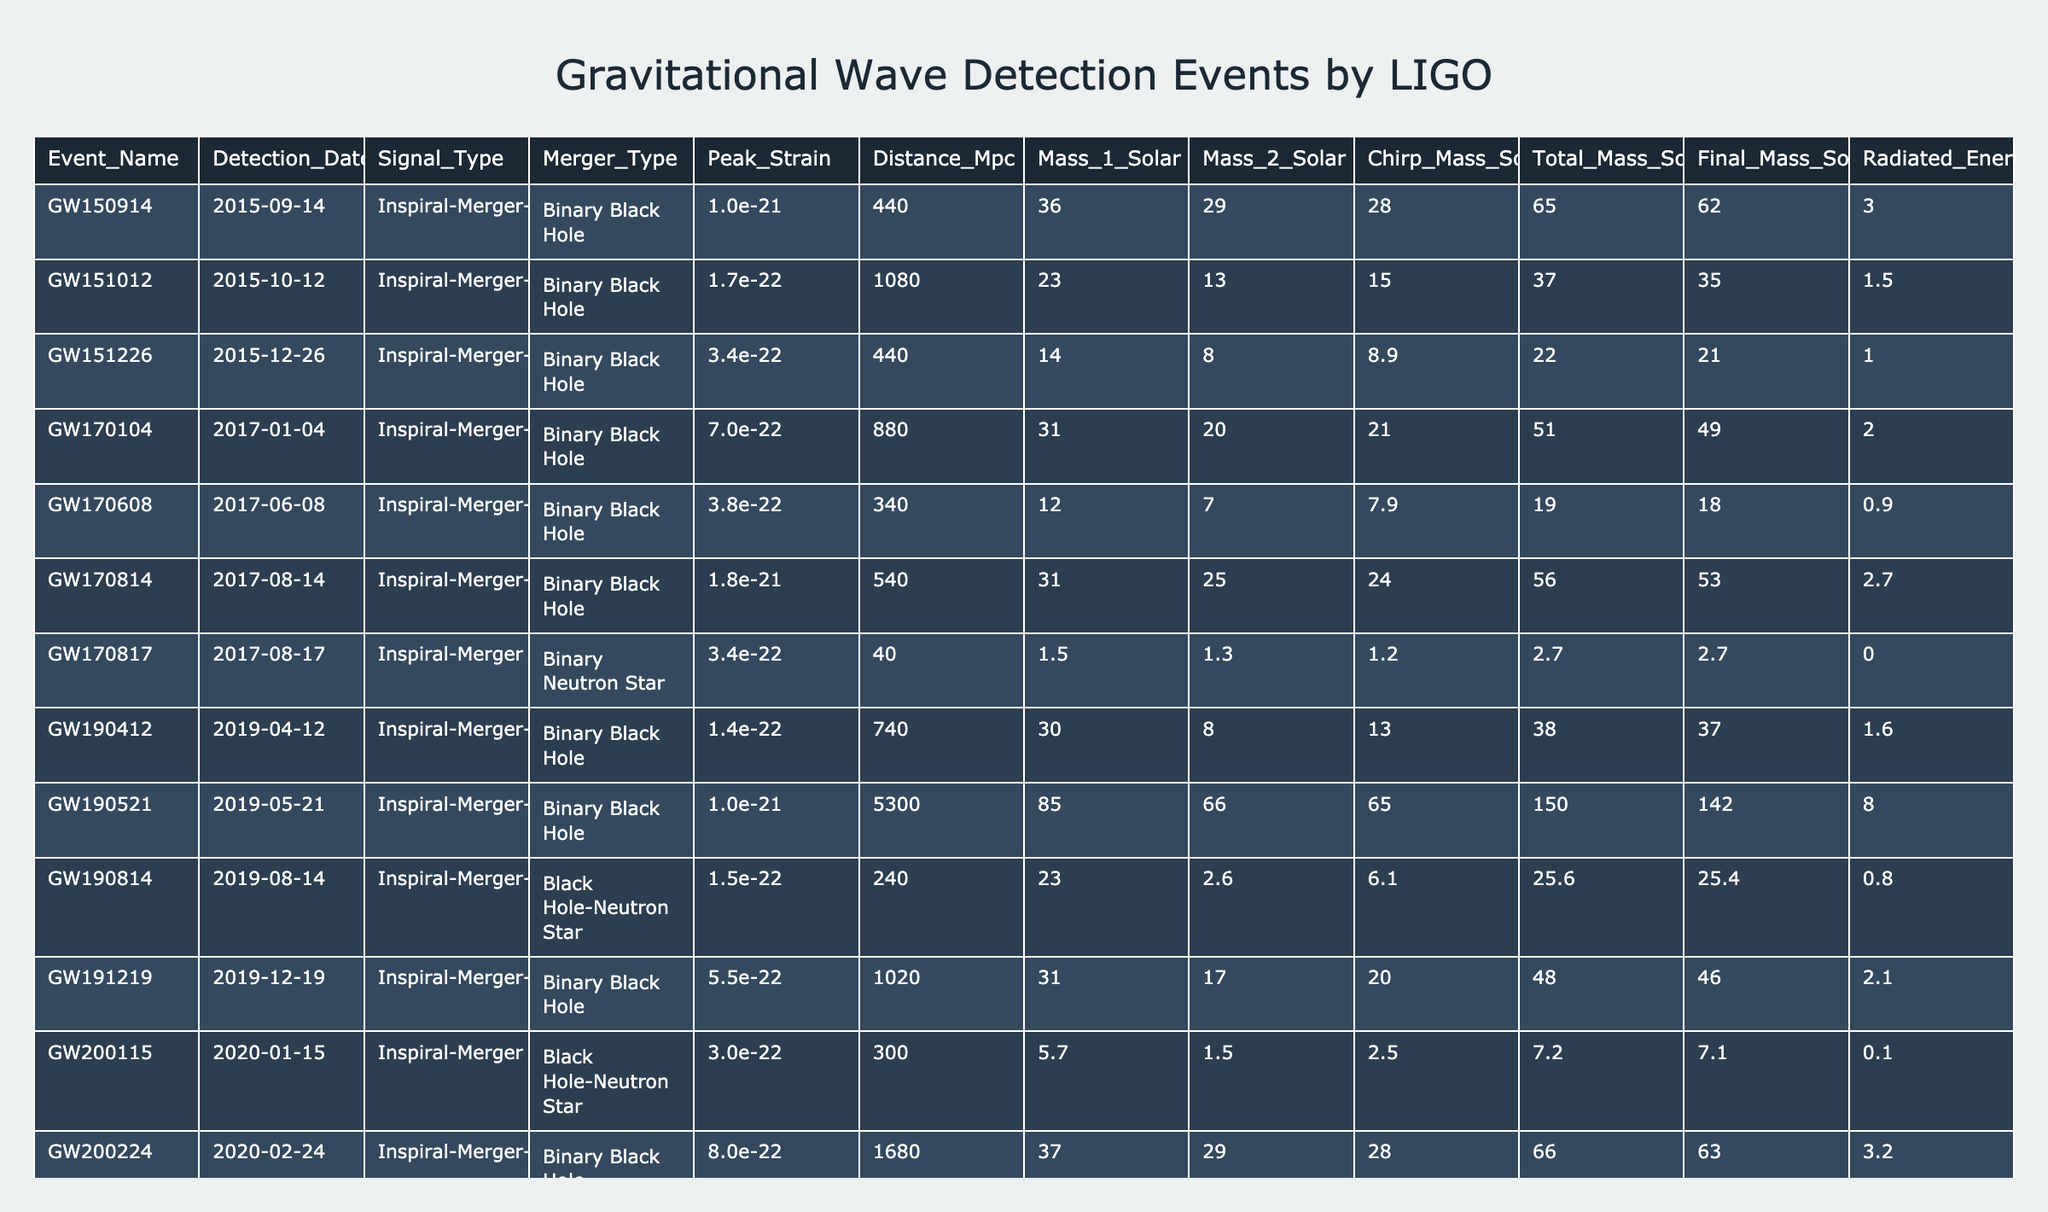What was the detection date of the event GW170817? The table lists each event with its corresponding detection date. To find the date for GW170817, I locate the row for that event, which shows the detection date as 2017-08-17.
Answer: 2017-08-17 What is the peak strain value of the event GW190521? The peak strain value can be found by looking at the column for peak strain corresponding to the row for GW190521. This entry shows a peak strain of 1.0e-21.
Answer: 1.0e-21 How many total solar masses was combined for the event GW200311? To find the total solar mass for GW200311, I check the total mass solar column for that event. The entry indicates a total mass of 73.0 solar masses.
Answer: 73.0 What are the masses of the two objects involved in the merger event GW151012? For GW151012, I look in the columns for mass 1 solar and mass 2 solar, which show values of 23.0 and 13.0 solar masses, respectively.
Answer: 23.0 and 13.0 Is the event GW170608 a binary black hole merger? I refer to the merger type column of GW170608. The entry states it is a 'Binary Black Hole', so the answer is yes.
Answer: Yes What is the average distance of all events detected in Mpc? To find the average distance, I sum all the distances listed in the distance Mpc column (440 + 1080 + 440 + 880 + 340 + 540 + 40 + 740 + 5300 + 240 + 1020 + 300 + 1680 + 2160) = 12420. Then divide by the number of events, which is 14. The average distance is 12420/14 = 887.14.
Answer: 887.14 Which event has the highest radiated energy? I examine the radiated energy solar column and identify the maximum value. GW190521 shows the highest radiated energy at 8.0 solar masses.
Answer: GW190521 How does the peak strain of the event GW170104 compare to GW151226? I check the peak strain values: GW170104 has a peak strain of 7.0e-22 and GW151226 has 3.4e-22. Comparing these, GW170104 has a higher peak strain.
Answer: Higher (GW170104) What is the total mass for the event GW190412? I look in the total mass solar column for GW190412, which shows a total mass of 38.0 solar masses.
Answer: 38.0 Which event occurred in the year 2019 had a binary neutron star merger type? Scanning the event rows, I find that GW170817 is the only entry that indicates 'Binary Neutron Star' as the type and it occurred in 2017, meaning there is no event from 2019 with this type.
Answer: None 